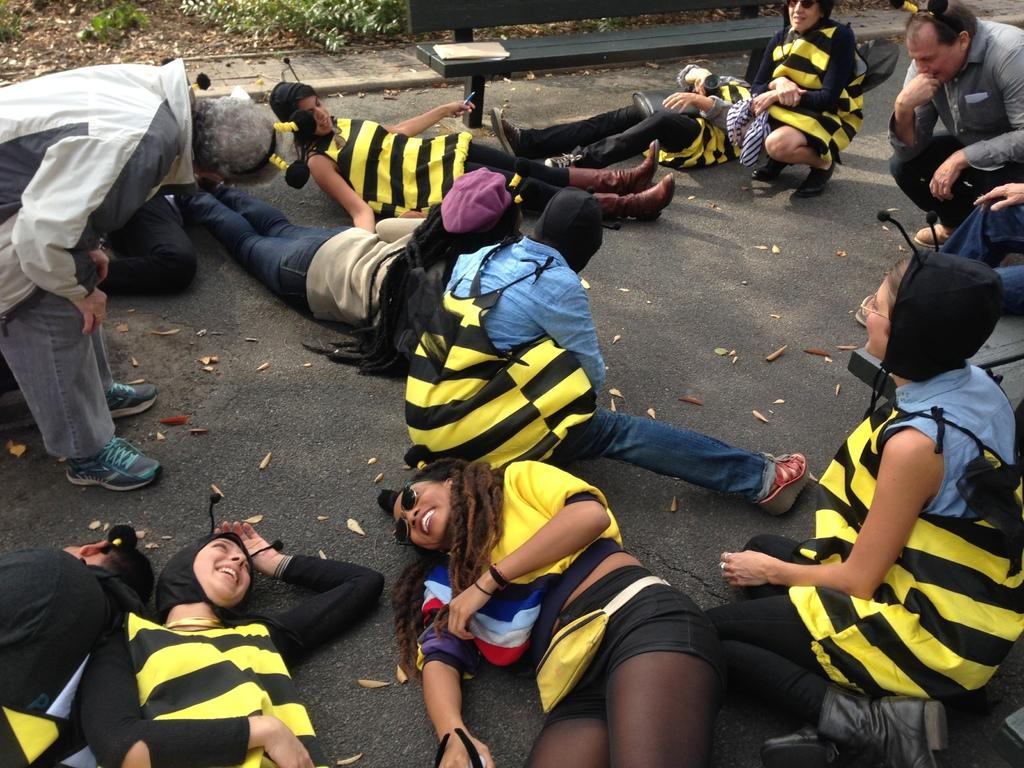How many people are in the image? There is a group of people in the image. What are the different positions of the people in the image? Some people are standing, some are sitting, and some are lying on the road. What can be seen in the background of the image? There is grass and a fence in the background of the image. What type of disgust can be seen on the faces of the people in the image? There is no indication of disgust on the faces of the people in the image. Where is the lunchroom located in the image? There is no mention of a lunchroom in the image. 